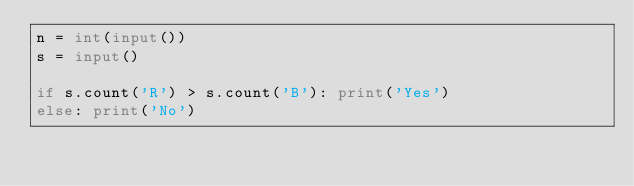Convert code to text. <code><loc_0><loc_0><loc_500><loc_500><_Python_>n = int(input())
s = input()

if s.count('R') > s.count('B'): print('Yes')
else: print('No')
</code> 